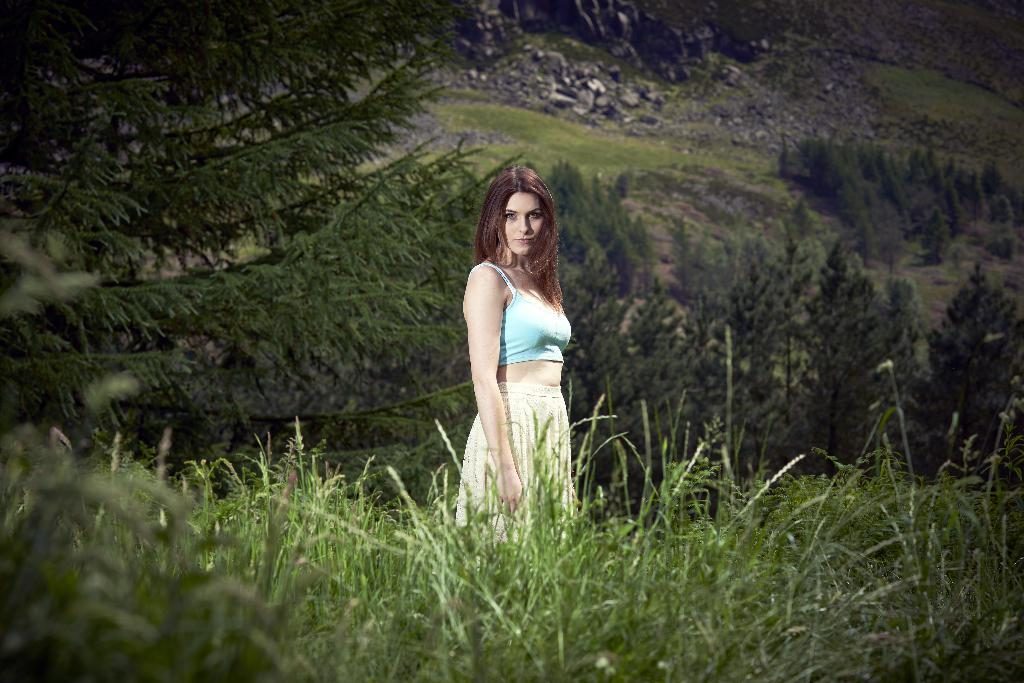What is the main subject of the image? There is a woman standing in the image. What is the woman standing on? The woman is standing on the ground. What type of vegetation can be seen in the image? There is grass visible in the image. What other natural elements are present in the image? There are trees and rocks in the image. What type of beam is being used by the woman in the image? There is no beam present in the image; the woman is simply standing on the ground. What time of day is it in the image, based on the presence of air? The presence of air is not an indicator of the time of day, and there is no specific information about the time of day in the image. 